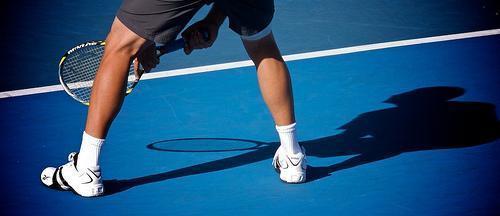How many tennis rackets are there?
Give a very brief answer. 1. How many slices of pizza are left of the fork?
Give a very brief answer. 0. 